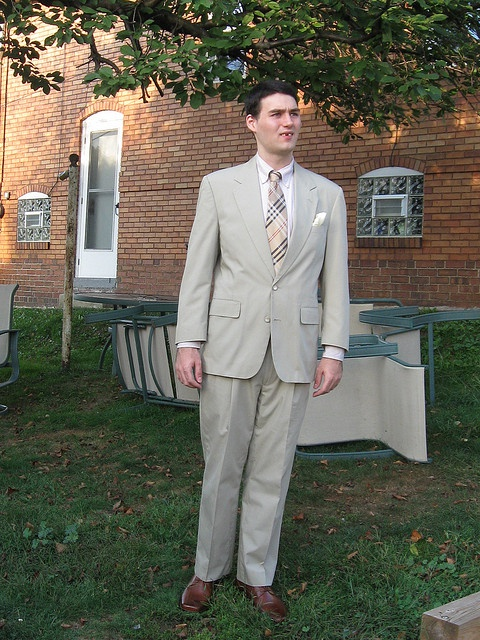Describe the objects in this image and their specific colors. I can see people in tan, darkgray, lightgray, gray, and black tones, chair in tan, black, gray, and purple tones, chair in tan, gray, purple, and black tones, bench in tan, black, gray, and purple tones, and chair in tan, black, gray, and purple tones in this image. 